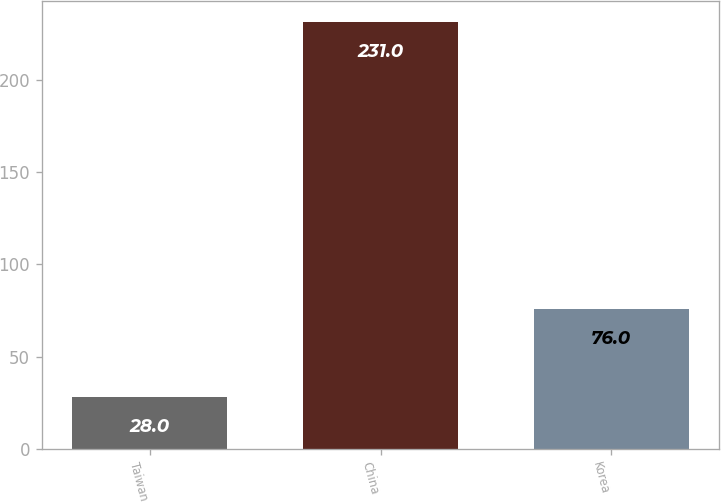<chart> <loc_0><loc_0><loc_500><loc_500><bar_chart><fcel>Taiwan<fcel>China<fcel>Korea<nl><fcel>28<fcel>231<fcel>76<nl></chart> 